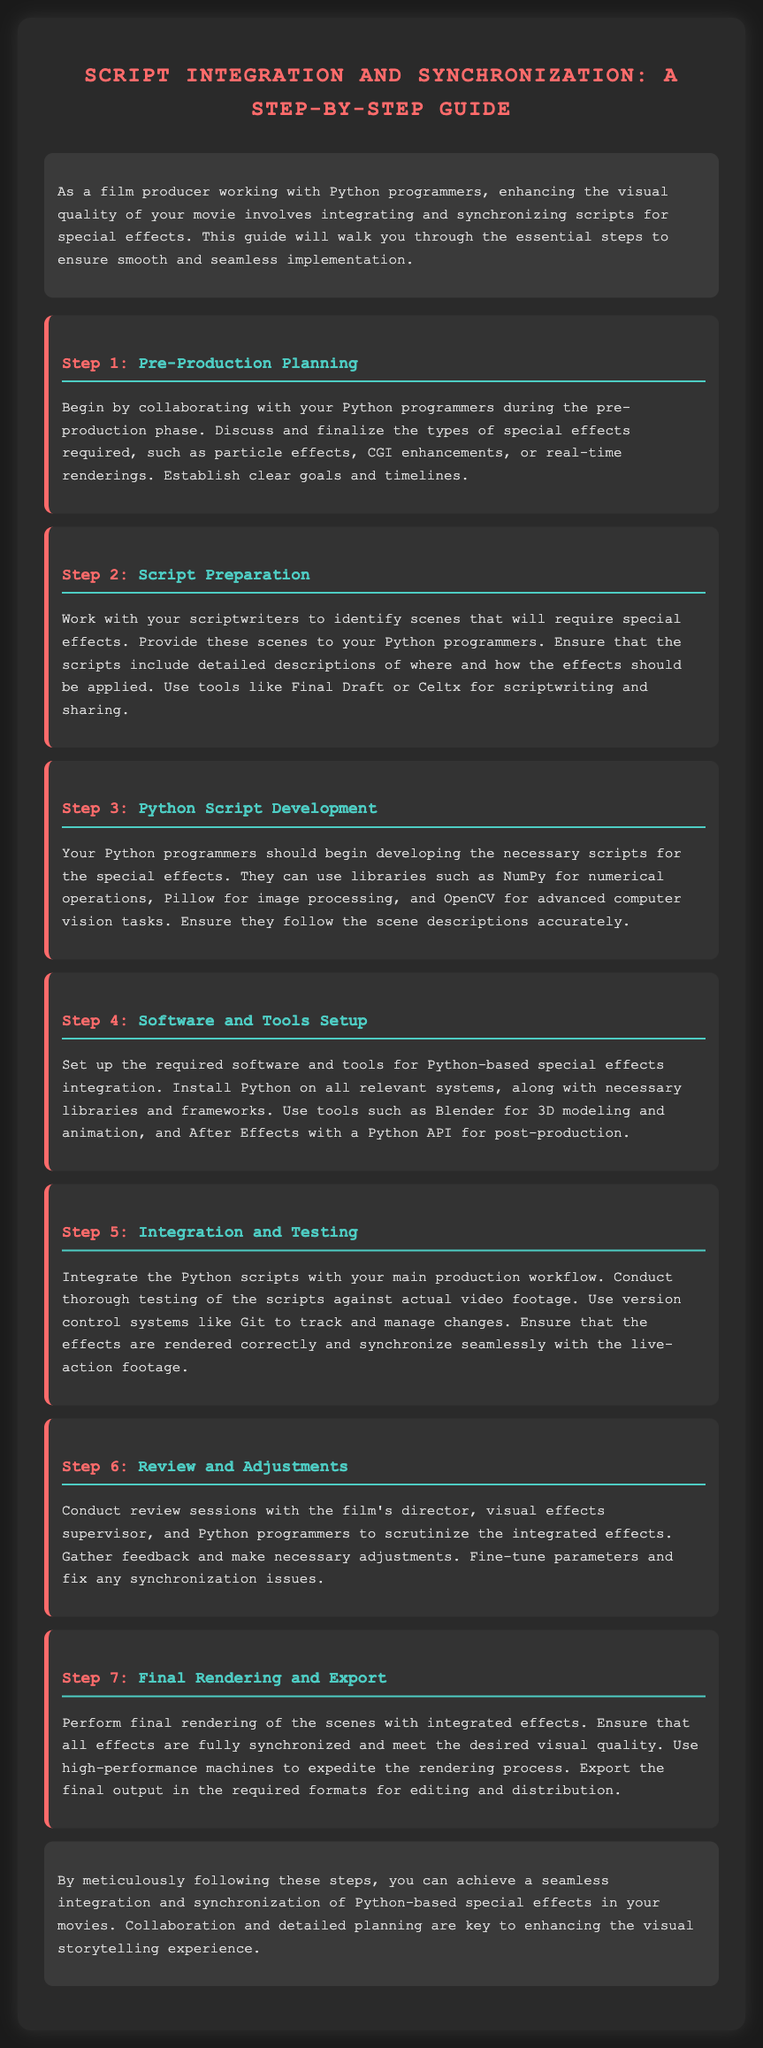What is the first step in the guide? The first step in the guide is "Pre-Production Planning."
Answer: Pre-Production Planning Which software is suggested for post-production? The guide suggests using After Effects with a Python API for post-production.
Answer: After Effects How many steps are outlined in the guide? The document outlines a total of seven steps for script integration and synchronization.
Answer: Seven What is the purpose of version control systems in the integration process? Version control systems like Git are used to track and manage changes during integration and testing.
Answer: Track changes What type of effects should be discussed during pre-production? The effects that should be discussed include particle effects, CGI enhancements, or real-time renderings.
Answer: Particle effects, CGI enhancements, real-time renderings What is the final step mentioned in the guide? The final step mentioned is "Final Rendering and Export."
Answer: Final Rendering and Export Which programming languages are primarily involved in the integration of special effects? The programming language primarily involved is Python.
Answer: Python What is necessary to ensure accurate synchronization of effects with live-action footage? Thorough testing of the scripts against actual video footage is necessary for accurate synchronization.
Answer: Thorough testing 